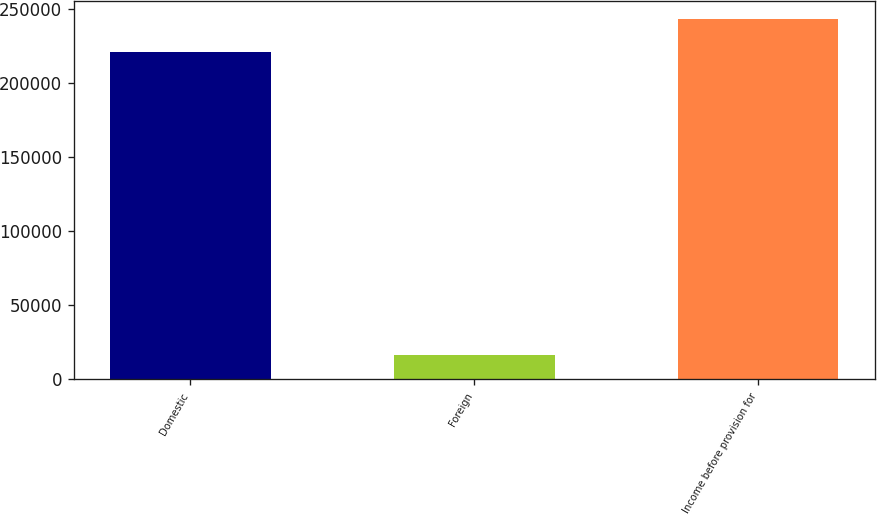Convert chart. <chart><loc_0><loc_0><loc_500><loc_500><bar_chart><fcel>Domestic<fcel>Foreign<fcel>Income before provision for<nl><fcel>221071<fcel>16161<fcel>243178<nl></chart> 